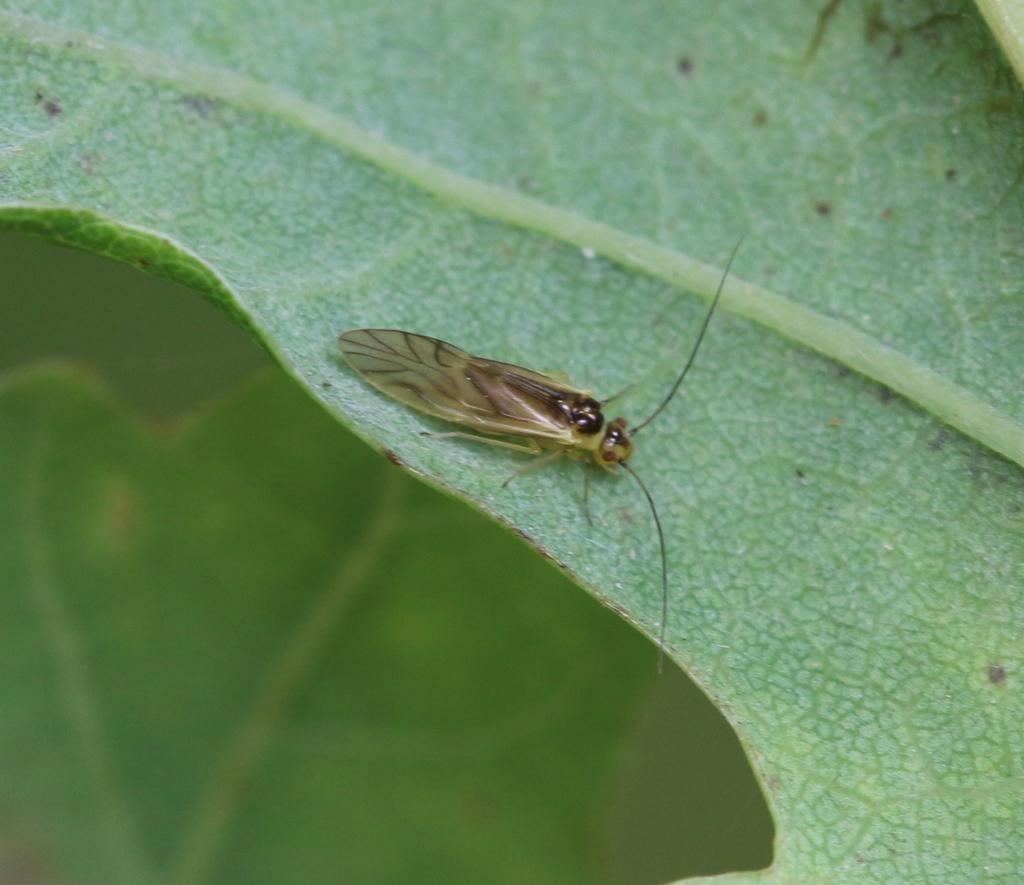Describe this image in one or two sentences. In this picture we can see one insert on the leaf. 